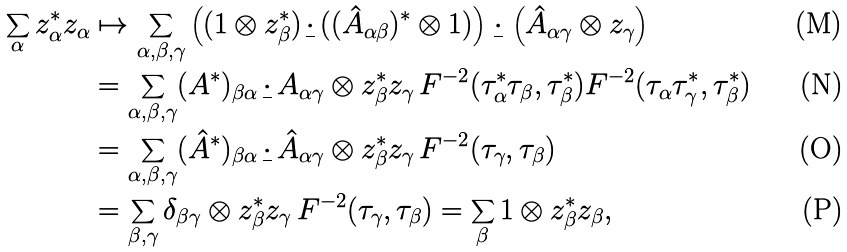Convert formula to latex. <formula><loc_0><loc_0><loc_500><loc_500>\sum _ { \alpha } z _ { \alpha } ^ { * } z _ { \alpha } & \mapsto \sum _ { \alpha , \beta , \gamma } \left ( ( 1 \otimes z _ { \beta } ^ { * } ) \, \underline { \cdot } \, ( ( \hat { A } _ { \alpha \beta } ) ^ { * } \otimes 1 ) \right ) \, \underline { \cdot } \, \left ( \hat { A } _ { \alpha \gamma } \otimes z _ { \gamma } \right ) \\ & = \sum _ { \alpha , \beta , \gamma } ( A ^ { * } ) _ { \beta \alpha } \, \underline { \cdot } \, A _ { \alpha \gamma } \otimes z _ { \beta } ^ { * } z _ { \gamma } \, F ^ { - 2 } ( \tau _ { \alpha } ^ { * } \tau _ { \beta } , \tau _ { \beta } ^ { * } ) F ^ { - 2 } ( \tau _ { \alpha } \tau _ { \gamma } ^ { * } , \tau _ { \beta } ^ { * } ) \\ & = \sum _ { \alpha , \beta , \gamma } ( \hat { A } ^ { * } ) _ { \beta \alpha } \, \underline { \cdot } \, \hat { A } _ { \alpha \gamma } \otimes z _ { \beta } ^ { * } z _ { \gamma } \, F ^ { - 2 } ( \tau _ { \gamma } , \tau _ { \beta } ) \\ & = \sum _ { \beta , \gamma } \delta _ { \beta \gamma } \otimes z _ { \beta } ^ { * } z _ { \gamma } \, F ^ { - 2 } ( \tau _ { \gamma } , \tau _ { \beta } ) = \sum _ { \beta } 1 \otimes z _ { \beta } ^ { * } z _ { \beta } ,</formula> 